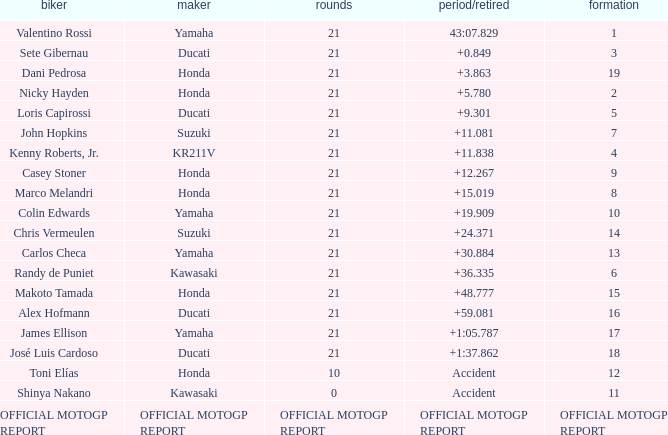What is the time/retired for the rider with the manufacturuer yamaha, grod of 1 and 21 total laps? 43:07.829. 